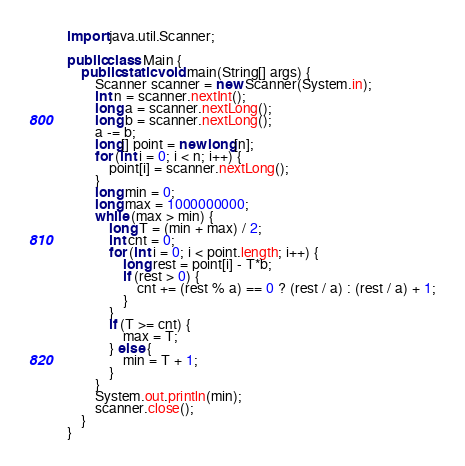Convert code to text. <code><loc_0><loc_0><loc_500><loc_500><_Java_>import java.util.Scanner;

public class Main {
	public static void main(String[] args) {
		Scanner scanner = new Scanner(System.in);
		int n = scanner.nextInt();
		long a = scanner.nextLong();
		long b = scanner.nextLong();
		a -= b; 
		long[] point = new long[n];
		for (int i = 0; i < n; i++) {
			point[i] = scanner.nextLong();
		}
		long min = 0;
		long max = 1000000000;
		while (max > min) {
			long T = (min + max) / 2;
			int cnt = 0;
			for (int i = 0; i < point.length; i++) {
				long rest = point[i] - T*b;
				if (rest > 0) {
					cnt += (rest % a) == 0 ? (rest / a) : (rest / a) + 1;
				}
			}
			if (T >= cnt) {
				max = T;
			} else {
				min = T + 1;
			}
		}
		System.out.println(min);
		scanner.close();
	}
}
</code> 